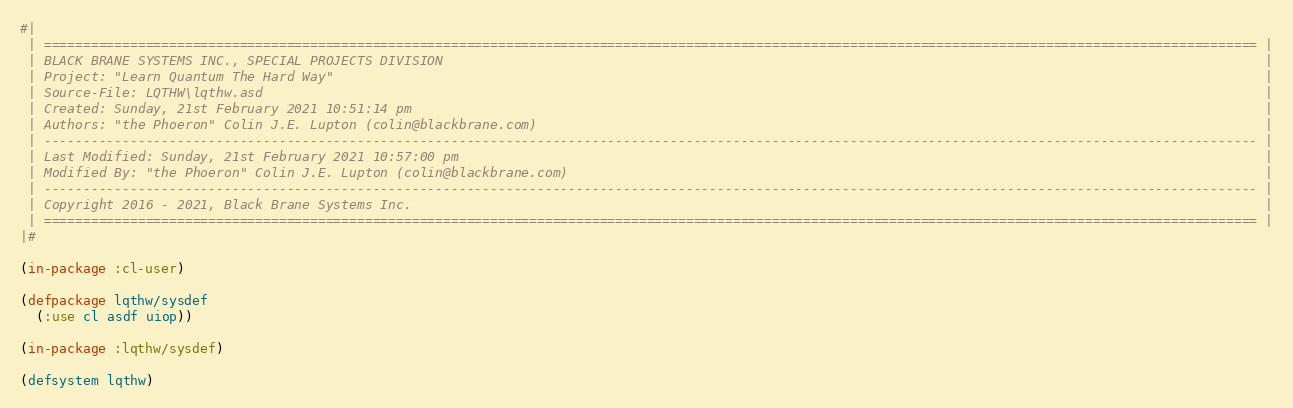Convert code to text. <code><loc_0><loc_0><loc_500><loc_500><_Lisp_>#|
 | =========================================================================================================================================================== |
 | BLACK BRANE SYSTEMS INC., SPECIAL PROJECTS DIVISION                                                                                                         |
 | Project: "Learn Quantum The Hard Way"                                                                                                                       |
 | Source-File: LQTHW\lqthw.asd                                                                                                                                |
 | Created: Sunday, 21st February 2021 10:51:14 pm                                                                                                             |
 | Authors: "the Phoeron" Colin J.E. Lupton (colin@blackbrane.com)                                                                                             |
 | ----------------------------------------------------------------------------------------------------------------------------------------------------------- |
 | Last Modified: Sunday, 21st February 2021 10:57:00 pm                                                                                                       |
 | Modified By: "the Phoeron" Colin J.E. Lupton (colin@blackbrane.com)                                                                                         |
 | ----------------------------------------------------------------------------------------------------------------------------------------------------------- |
 | Copyright 2016 - 2021, Black Brane Systems Inc.                                                                                                             |
 | =========================================================================================================================================================== |
|#

(in-package :cl-user)

(defpackage lqthw/sysdef
  (:use cl asdf uiop))

(in-package :lqthw/sysdef)

(defsystem lqthw)
</code> 